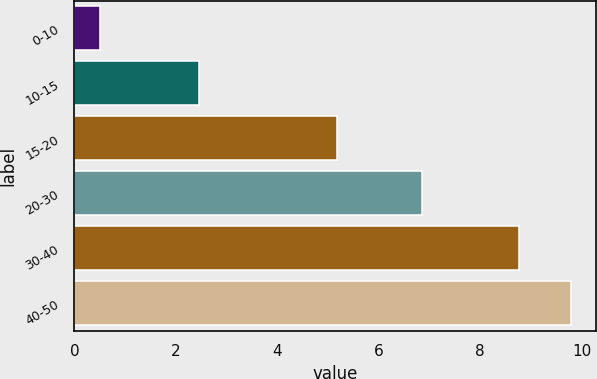Convert chart to OTSL. <chart><loc_0><loc_0><loc_500><loc_500><bar_chart><fcel>0-10<fcel>10-15<fcel>15-20<fcel>20-30<fcel>30-40<fcel>40-50<nl><fcel>0.51<fcel>2.46<fcel>5.17<fcel>6.85<fcel>8.76<fcel>9.79<nl></chart> 